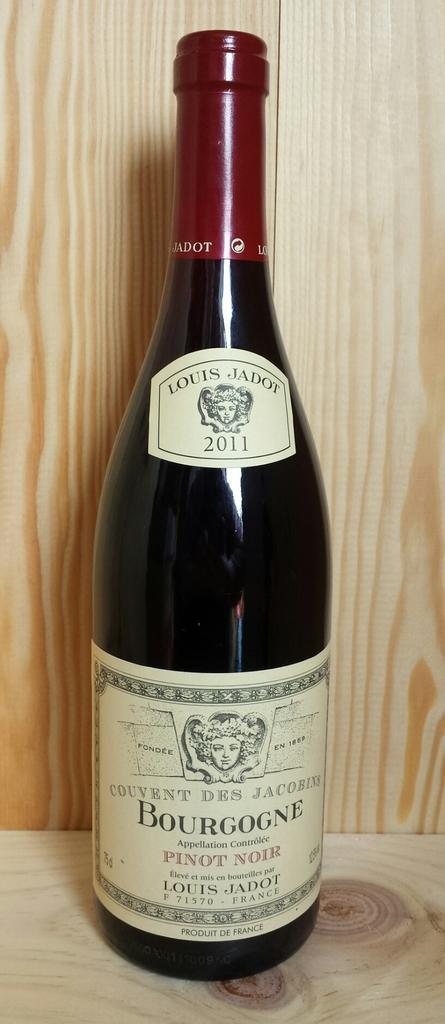How would you summarize this image in a sentence or two? There is a wine bottle which has something written on it. 